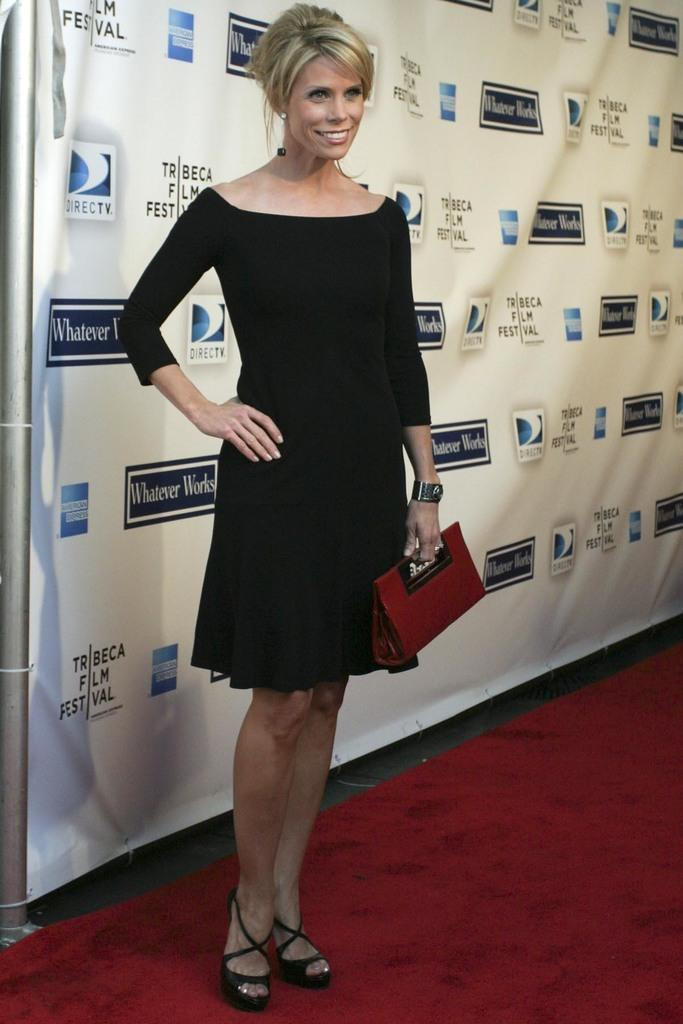What is the main subject of the image? There is a person standing in the image. What is the person standing on? The person is standing on a red carpet. How is the person's facial expression in the image? The person is wearing a smile on their face. What can be seen in the background of the image? There is a banner in the background of the image. How many boots can be seen on the person in the image? There are no boots visible in the image; the person is not wearing any footwear. Are there any spiders crawling on the person in the image? There are no spiders present in the image; the person is standing alone on the red carpet. 